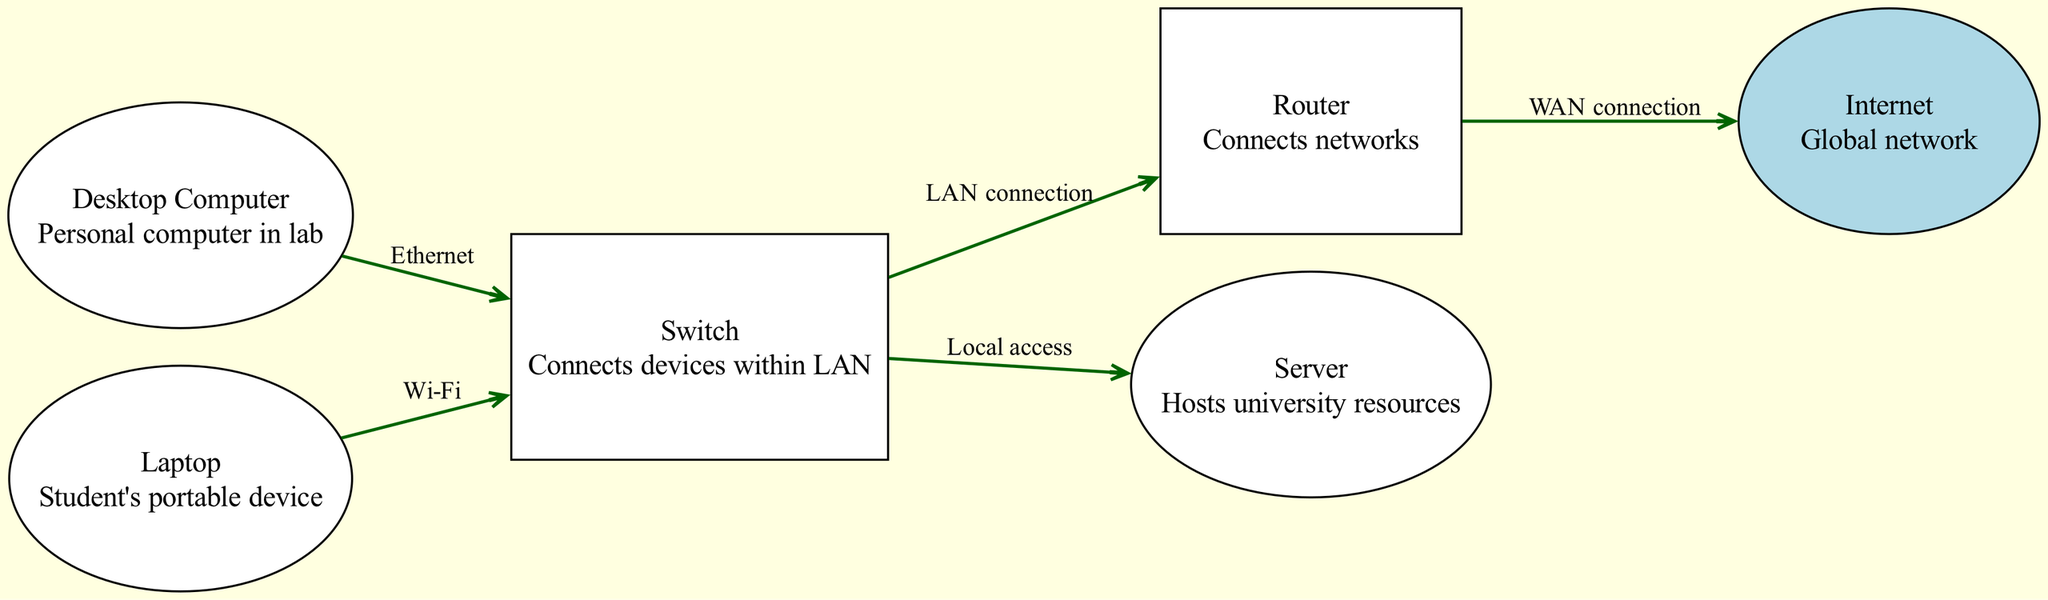What is the total number of devices in the network? The diagram includes six nodes: Desktop Computer, Laptop, Router, Switch, Server, and Internet. Therefore, by counting these nodes, we find that there are a total of six devices.
Answer: Six What type of connection does the Desktop Computer use to connect to the Switch? According to the diagram, the Desktop Computer connects to the Switch via an Ethernet connection, as specified by the edge connecting these two nodes.
Answer: Ethernet Which device has a WAN connection? The only device with a WAN connection is the Router. This is indicated by the connection between the Router and the Internet, labeled "WAN connection."
Answer: Router How many connections are there in total? The diagram includes five edges, indicating the various connections between the devices in the network. By counting these edges, we can confirm the total number of connections is five.
Answer: Five What is the function of the Switch? The Switch connects devices within a Local Area Network (LAN). This is detailed in the description of the Switch node in the diagram.
Answer: Connects devices within LAN Which devices are connected to the Switch? The Desktop Computer and Laptop are both directly connected to the Switch, as shown by the edges leading from each device to the Switch in the diagram.
Answer: Desktop Computer and Laptop What type of connection does the Laptop use to connect to the Switch? The Laptop connects to the Switch using a Wi-Fi connection, as shown in the edge labeled "Wi-Fi" between the two nodes.
Answer: Wi-Fi What is the main purpose of the Server in this network? The primary purpose of the Server, as described in the diagram, is to host university resources, allowing access for connected devices within the network.
Answer: Hosts university resources 